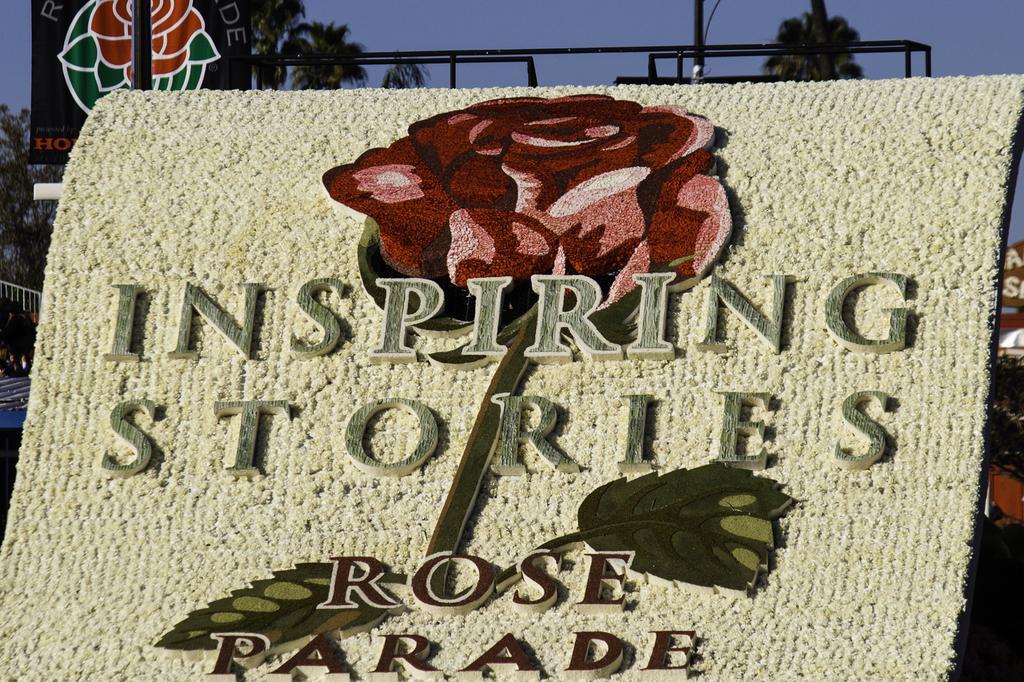Please provide a concise description of this image. Here in this picture we can see a cloth and on that we can see a rose design present and we can see some text written on it and behind that we can see some banners present and we can see trees present all over there. 